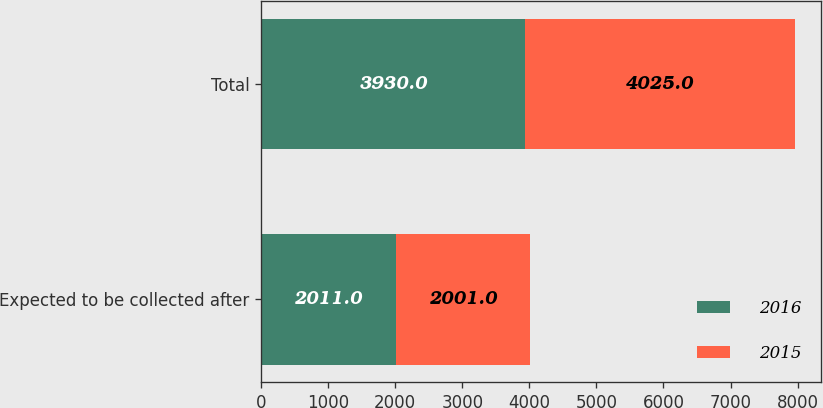Convert chart. <chart><loc_0><loc_0><loc_500><loc_500><stacked_bar_chart><ecel><fcel>Expected to be collected after<fcel>Total<nl><fcel>2016<fcel>2011<fcel>3930<nl><fcel>2015<fcel>2001<fcel>4025<nl></chart> 